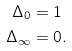Convert formula to latex. <formula><loc_0><loc_0><loc_500><loc_500>\Delta _ { 0 } & = 1 \\ \Delta _ { \infty } & = 0 .</formula> 